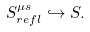Convert formula to latex. <formula><loc_0><loc_0><loc_500><loc_500>S ^ { \mu s } _ { r e f l } \hookrightarrow S .</formula> 